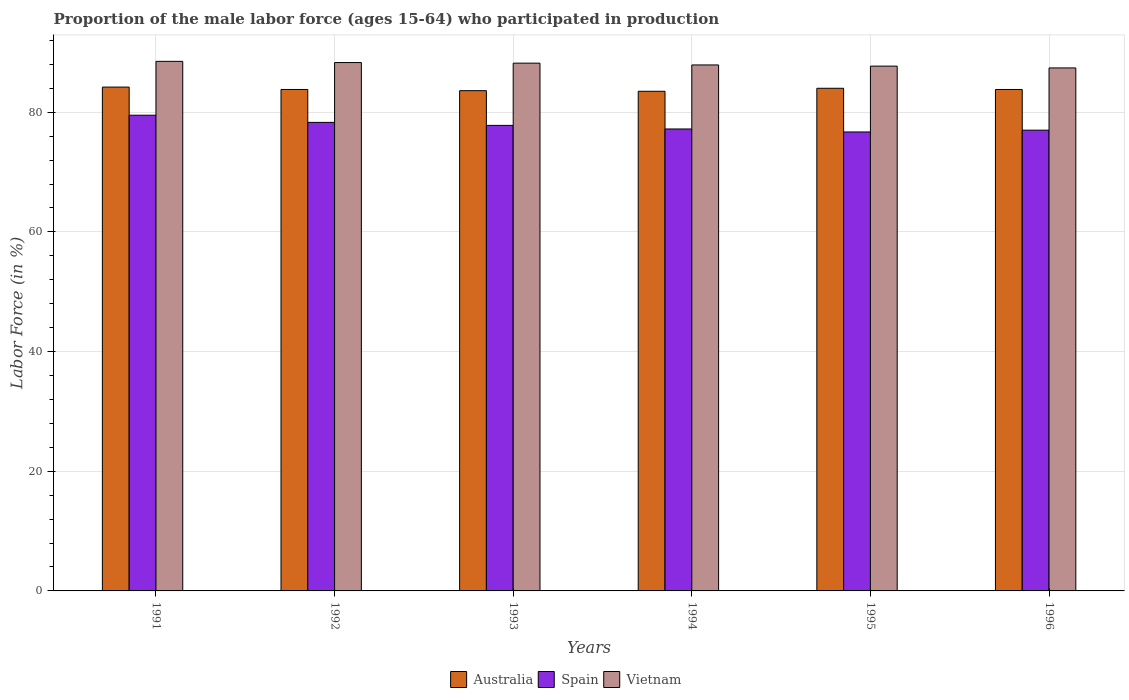How many different coloured bars are there?
Give a very brief answer. 3. How many groups of bars are there?
Your answer should be compact. 6. Are the number of bars per tick equal to the number of legend labels?
Give a very brief answer. Yes. Are the number of bars on each tick of the X-axis equal?
Give a very brief answer. Yes. How many bars are there on the 2nd tick from the left?
Make the answer very short. 3. In how many cases, is the number of bars for a given year not equal to the number of legend labels?
Provide a succinct answer. 0. What is the proportion of the male labor force who participated in production in Vietnam in 1995?
Keep it short and to the point. 87.7. Across all years, what is the maximum proportion of the male labor force who participated in production in Spain?
Provide a succinct answer. 79.5. Across all years, what is the minimum proportion of the male labor force who participated in production in Vietnam?
Offer a terse response. 87.4. In which year was the proportion of the male labor force who participated in production in Spain minimum?
Provide a succinct answer. 1995. What is the total proportion of the male labor force who participated in production in Vietnam in the graph?
Ensure brevity in your answer.  528. What is the difference between the proportion of the male labor force who participated in production in Vietnam in 1992 and that in 1994?
Ensure brevity in your answer.  0.4. What is the difference between the proportion of the male labor force who participated in production in Australia in 1992 and the proportion of the male labor force who participated in production in Vietnam in 1993?
Ensure brevity in your answer.  -4.4. In the year 1992, what is the difference between the proportion of the male labor force who participated in production in Australia and proportion of the male labor force who participated in production in Spain?
Ensure brevity in your answer.  5.5. In how many years, is the proportion of the male labor force who participated in production in Vietnam greater than 88 %?
Provide a succinct answer. 3. What is the ratio of the proportion of the male labor force who participated in production in Vietnam in 1993 to that in 1995?
Provide a succinct answer. 1.01. Is the proportion of the male labor force who participated in production in Australia in 1991 less than that in 1995?
Your answer should be compact. No. Is the difference between the proportion of the male labor force who participated in production in Australia in 1992 and 1994 greater than the difference between the proportion of the male labor force who participated in production in Spain in 1992 and 1994?
Provide a succinct answer. No. What is the difference between the highest and the second highest proportion of the male labor force who participated in production in Australia?
Offer a terse response. 0.2. What is the difference between the highest and the lowest proportion of the male labor force who participated in production in Spain?
Offer a terse response. 2.8. In how many years, is the proportion of the male labor force who participated in production in Australia greater than the average proportion of the male labor force who participated in production in Australia taken over all years?
Your response must be concise. 2. What does the 1st bar from the left in 1991 represents?
Keep it short and to the point. Australia. Is it the case that in every year, the sum of the proportion of the male labor force who participated in production in Spain and proportion of the male labor force who participated in production in Vietnam is greater than the proportion of the male labor force who participated in production in Australia?
Your answer should be very brief. Yes. How many bars are there?
Your answer should be compact. 18. Are all the bars in the graph horizontal?
Your response must be concise. No. What is the difference between two consecutive major ticks on the Y-axis?
Your response must be concise. 20. Does the graph contain any zero values?
Ensure brevity in your answer.  No. How many legend labels are there?
Make the answer very short. 3. How are the legend labels stacked?
Provide a succinct answer. Horizontal. What is the title of the graph?
Your answer should be compact. Proportion of the male labor force (ages 15-64) who participated in production. What is the Labor Force (in %) of Australia in 1991?
Make the answer very short. 84.2. What is the Labor Force (in %) in Spain in 1991?
Offer a very short reply. 79.5. What is the Labor Force (in %) of Vietnam in 1991?
Provide a short and direct response. 88.5. What is the Labor Force (in %) of Australia in 1992?
Provide a succinct answer. 83.8. What is the Labor Force (in %) in Spain in 1992?
Your response must be concise. 78.3. What is the Labor Force (in %) in Vietnam in 1992?
Keep it short and to the point. 88.3. What is the Labor Force (in %) of Australia in 1993?
Your answer should be compact. 83.6. What is the Labor Force (in %) in Spain in 1993?
Offer a very short reply. 77.8. What is the Labor Force (in %) in Vietnam in 1993?
Provide a succinct answer. 88.2. What is the Labor Force (in %) in Australia in 1994?
Offer a very short reply. 83.5. What is the Labor Force (in %) in Spain in 1994?
Your answer should be compact. 77.2. What is the Labor Force (in %) in Vietnam in 1994?
Ensure brevity in your answer.  87.9. What is the Labor Force (in %) of Spain in 1995?
Keep it short and to the point. 76.7. What is the Labor Force (in %) of Vietnam in 1995?
Keep it short and to the point. 87.7. What is the Labor Force (in %) of Australia in 1996?
Give a very brief answer. 83.8. What is the Labor Force (in %) in Spain in 1996?
Your answer should be very brief. 77. What is the Labor Force (in %) in Vietnam in 1996?
Your answer should be very brief. 87.4. Across all years, what is the maximum Labor Force (in %) of Australia?
Provide a succinct answer. 84.2. Across all years, what is the maximum Labor Force (in %) of Spain?
Your answer should be compact. 79.5. Across all years, what is the maximum Labor Force (in %) in Vietnam?
Keep it short and to the point. 88.5. Across all years, what is the minimum Labor Force (in %) of Australia?
Make the answer very short. 83.5. Across all years, what is the minimum Labor Force (in %) in Spain?
Your answer should be compact. 76.7. Across all years, what is the minimum Labor Force (in %) of Vietnam?
Your answer should be compact. 87.4. What is the total Labor Force (in %) in Australia in the graph?
Provide a short and direct response. 502.9. What is the total Labor Force (in %) of Spain in the graph?
Offer a very short reply. 466.5. What is the total Labor Force (in %) in Vietnam in the graph?
Your answer should be very brief. 528. What is the difference between the Labor Force (in %) in Spain in 1991 and that in 1992?
Your answer should be compact. 1.2. What is the difference between the Labor Force (in %) of Vietnam in 1991 and that in 1992?
Offer a very short reply. 0.2. What is the difference between the Labor Force (in %) of Spain in 1991 and that in 1993?
Your response must be concise. 1.7. What is the difference between the Labor Force (in %) in Spain in 1991 and that in 1994?
Offer a very short reply. 2.3. What is the difference between the Labor Force (in %) of Vietnam in 1991 and that in 1994?
Keep it short and to the point. 0.6. What is the difference between the Labor Force (in %) in Australia in 1991 and that in 1995?
Give a very brief answer. 0.2. What is the difference between the Labor Force (in %) in Spain in 1991 and that in 1995?
Your answer should be compact. 2.8. What is the difference between the Labor Force (in %) in Australia in 1991 and that in 1996?
Your response must be concise. 0.4. What is the difference between the Labor Force (in %) in Vietnam in 1991 and that in 1996?
Ensure brevity in your answer.  1.1. What is the difference between the Labor Force (in %) in Australia in 1992 and that in 1993?
Provide a succinct answer. 0.2. What is the difference between the Labor Force (in %) of Vietnam in 1992 and that in 1993?
Provide a short and direct response. 0.1. What is the difference between the Labor Force (in %) in Vietnam in 1992 and that in 1994?
Your answer should be compact. 0.4. What is the difference between the Labor Force (in %) of Australia in 1992 and that in 1995?
Give a very brief answer. -0.2. What is the difference between the Labor Force (in %) in Vietnam in 1992 and that in 1995?
Make the answer very short. 0.6. What is the difference between the Labor Force (in %) of Australia in 1992 and that in 1996?
Your response must be concise. 0. What is the difference between the Labor Force (in %) in Vietnam in 1992 and that in 1996?
Make the answer very short. 0.9. What is the difference between the Labor Force (in %) of Vietnam in 1993 and that in 1994?
Keep it short and to the point. 0.3. What is the difference between the Labor Force (in %) in Australia in 1993 and that in 1995?
Make the answer very short. -0.4. What is the difference between the Labor Force (in %) of Spain in 1993 and that in 1996?
Provide a short and direct response. 0.8. What is the difference between the Labor Force (in %) of Vietnam in 1994 and that in 1995?
Offer a very short reply. 0.2. What is the difference between the Labor Force (in %) of Vietnam in 1994 and that in 1996?
Offer a very short reply. 0.5. What is the difference between the Labor Force (in %) in Australia in 1995 and that in 1996?
Provide a succinct answer. 0.2. What is the difference between the Labor Force (in %) in Vietnam in 1995 and that in 1996?
Provide a succinct answer. 0.3. What is the difference between the Labor Force (in %) in Australia in 1991 and the Labor Force (in %) in Spain in 1992?
Offer a terse response. 5.9. What is the difference between the Labor Force (in %) in Australia in 1991 and the Labor Force (in %) in Spain in 1993?
Offer a terse response. 6.4. What is the difference between the Labor Force (in %) in Australia in 1991 and the Labor Force (in %) in Vietnam in 1993?
Make the answer very short. -4. What is the difference between the Labor Force (in %) of Spain in 1991 and the Labor Force (in %) of Vietnam in 1993?
Provide a succinct answer. -8.7. What is the difference between the Labor Force (in %) in Spain in 1991 and the Labor Force (in %) in Vietnam in 1994?
Your answer should be very brief. -8.4. What is the difference between the Labor Force (in %) of Australia in 1991 and the Labor Force (in %) of Spain in 1995?
Your answer should be compact. 7.5. What is the difference between the Labor Force (in %) of Australia in 1991 and the Labor Force (in %) of Vietnam in 1996?
Your answer should be compact. -3.2. What is the difference between the Labor Force (in %) in Australia in 1992 and the Labor Force (in %) in Vietnam in 1993?
Offer a terse response. -4.4. What is the difference between the Labor Force (in %) in Australia in 1992 and the Labor Force (in %) in Vietnam in 1994?
Offer a very short reply. -4.1. What is the difference between the Labor Force (in %) in Australia in 1992 and the Labor Force (in %) in Spain in 1995?
Your answer should be very brief. 7.1. What is the difference between the Labor Force (in %) of Australia in 1992 and the Labor Force (in %) of Vietnam in 1995?
Your answer should be compact. -3.9. What is the difference between the Labor Force (in %) in Spain in 1992 and the Labor Force (in %) in Vietnam in 1995?
Make the answer very short. -9.4. What is the difference between the Labor Force (in %) in Australia in 1992 and the Labor Force (in %) in Vietnam in 1996?
Provide a succinct answer. -3.6. What is the difference between the Labor Force (in %) in Australia in 1993 and the Labor Force (in %) in Vietnam in 1994?
Make the answer very short. -4.3. What is the difference between the Labor Force (in %) in Australia in 1993 and the Labor Force (in %) in Vietnam in 1995?
Keep it short and to the point. -4.1. What is the difference between the Labor Force (in %) in Australia in 1993 and the Labor Force (in %) in Vietnam in 1996?
Offer a very short reply. -3.8. What is the difference between the Labor Force (in %) of Australia in 1994 and the Labor Force (in %) of Spain in 1995?
Provide a succinct answer. 6.8. What is the difference between the Labor Force (in %) in Australia in 1994 and the Labor Force (in %) in Vietnam in 1995?
Give a very brief answer. -4.2. What is the difference between the Labor Force (in %) in Spain in 1994 and the Labor Force (in %) in Vietnam in 1996?
Your answer should be compact. -10.2. What is the difference between the Labor Force (in %) of Australia in 1995 and the Labor Force (in %) of Spain in 1996?
Offer a very short reply. 7. What is the difference between the Labor Force (in %) of Australia in 1995 and the Labor Force (in %) of Vietnam in 1996?
Keep it short and to the point. -3.4. What is the average Labor Force (in %) in Australia per year?
Your answer should be compact. 83.82. What is the average Labor Force (in %) in Spain per year?
Your response must be concise. 77.75. What is the average Labor Force (in %) of Vietnam per year?
Offer a terse response. 88. In the year 1991, what is the difference between the Labor Force (in %) of Australia and Labor Force (in %) of Spain?
Your answer should be very brief. 4.7. In the year 1992, what is the difference between the Labor Force (in %) of Australia and Labor Force (in %) of Spain?
Ensure brevity in your answer.  5.5. In the year 1992, what is the difference between the Labor Force (in %) in Australia and Labor Force (in %) in Vietnam?
Offer a very short reply. -4.5. In the year 1993, what is the difference between the Labor Force (in %) in Australia and Labor Force (in %) in Spain?
Provide a succinct answer. 5.8. In the year 1993, what is the difference between the Labor Force (in %) in Spain and Labor Force (in %) in Vietnam?
Your answer should be very brief. -10.4. In the year 1994, what is the difference between the Labor Force (in %) of Australia and Labor Force (in %) of Vietnam?
Offer a terse response. -4.4. In the year 1995, what is the difference between the Labor Force (in %) in Australia and Labor Force (in %) in Spain?
Provide a short and direct response. 7.3. In the year 1995, what is the difference between the Labor Force (in %) of Australia and Labor Force (in %) of Vietnam?
Keep it short and to the point. -3.7. In the year 1995, what is the difference between the Labor Force (in %) of Spain and Labor Force (in %) of Vietnam?
Your answer should be very brief. -11. In the year 1996, what is the difference between the Labor Force (in %) in Australia and Labor Force (in %) in Vietnam?
Offer a very short reply. -3.6. In the year 1996, what is the difference between the Labor Force (in %) of Spain and Labor Force (in %) of Vietnam?
Ensure brevity in your answer.  -10.4. What is the ratio of the Labor Force (in %) of Spain in 1991 to that in 1992?
Offer a terse response. 1.02. What is the ratio of the Labor Force (in %) of Vietnam in 1991 to that in 1992?
Offer a terse response. 1. What is the ratio of the Labor Force (in %) in Australia in 1991 to that in 1993?
Your answer should be compact. 1.01. What is the ratio of the Labor Force (in %) in Spain in 1991 to that in 1993?
Your answer should be compact. 1.02. What is the ratio of the Labor Force (in %) of Vietnam in 1991 to that in 1993?
Give a very brief answer. 1. What is the ratio of the Labor Force (in %) in Australia in 1991 to that in 1994?
Your response must be concise. 1.01. What is the ratio of the Labor Force (in %) in Spain in 1991 to that in 1994?
Make the answer very short. 1.03. What is the ratio of the Labor Force (in %) in Vietnam in 1991 to that in 1994?
Give a very brief answer. 1.01. What is the ratio of the Labor Force (in %) in Spain in 1991 to that in 1995?
Your response must be concise. 1.04. What is the ratio of the Labor Force (in %) in Vietnam in 1991 to that in 1995?
Provide a succinct answer. 1.01. What is the ratio of the Labor Force (in %) in Australia in 1991 to that in 1996?
Your response must be concise. 1. What is the ratio of the Labor Force (in %) in Spain in 1991 to that in 1996?
Keep it short and to the point. 1.03. What is the ratio of the Labor Force (in %) of Vietnam in 1991 to that in 1996?
Your answer should be very brief. 1.01. What is the ratio of the Labor Force (in %) in Spain in 1992 to that in 1993?
Ensure brevity in your answer.  1.01. What is the ratio of the Labor Force (in %) in Spain in 1992 to that in 1994?
Keep it short and to the point. 1.01. What is the ratio of the Labor Force (in %) in Vietnam in 1992 to that in 1994?
Offer a terse response. 1. What is the ratio of the Labor Force (in %) in Australia in 1992 to that in 1995?
Offer a terse response. 1. What is the ratio of the Labor Force (in %) of Spain in 1992 to that in 1995?
Your answer should be very brief. 1.02. What is the ratio of the Labor Force (in %) of Vietnam in 1992 to that in 1995?
Provide a succinct answer. 1.01. What is the ratio of the Labor Force (in %) of Australia in 1992 to that in 1996?
Offer a terse response. 1. What is the ratio of the Labor Force (in %) in Spain in 1992 to that in 1996?
Offer a terse response. 1.02. What is the ratio of the Labor Force (in %) of Vietnam in 1992 to that in 1996?
Your response must be concise. 1.01. What is the ratio of the Labor Force (in %) in Spain in 1993 to that in 1995?
Your answer should be compact. 1.01. What is the ratio of the Labor Force (in %) in Australia in 1993 to that in 1996?
Provide a short and direct response. 1. What is the ratio of the Labor Force (in %) in Spain in 1993 to that in 1996?
Make the answer very short. 1.01. What is the ratio of the Labor Force (in %) in Vietnam in 1993 to that in 1996?
Offer a very short reply. 1.01. What is the ratio of the Labor Force (in %) of Australia in 1994 to that in 1995?
Your answer should be very brief. 0.99. What is the ratio of the Labor Force (in %) in Spain in 1994 to that in 1995?
Offer a very short reply. 1.01. What is the ratio of the Labor Force (in %) in Vietnam in 1994 to that in 1996?
Offer a very short reply. 1.01. What is the ratio of the Labor Force (in %) of Australia in 1995 to that in 1996?
Provide a succinct answer. 1. What is the ratio of the Labor Force (in %) in Spain in 1995 to that in 1996?
Your answer should be very brief. 1. What is the ratio of the Labor Force (in %) in Vietnam in 1995 to that in 1996?
Give a very brief answer. 1. What is the difference between the highest and the second highest Labor Force (in %) of Vietnam?
Give a very brief answer. 0.2. What is the difference between the highest and the lowest Labor Force (in %) in Australia?
Your answer should be compact. 0.7. What is the difference between the highest and the lowest Labor Force (in %) of Spain?
Your response must be concise. 2.8. 